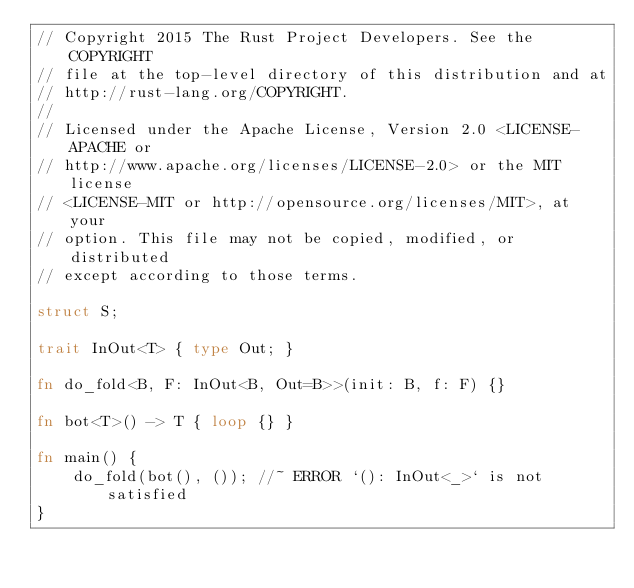Convert code to text. <code><loc_0><loc_0><loc_500><loc_500><_Rust_>// Copyright 2015 The Rust Project Developers. See the COPYRIGHT
// file at the top-level directory of this distribution and at
// http://rust-lang.org/COPYRIGHT.
//
// Licensed under the Apache License, Version 2.0 <LICENSE-APACHE or
// http://www.apache.org/licenses/LICENSE-2.0> or the MIT license
// <LICENSE-MIT or http://opensource.org/licenses/MIT>, at your
// option. This file may not be copied, modified, or distributed
// except according to those terms.

struct S;

trait InOut<T> { type Out; }

fn do_fold<B, F: InOut<B, Out=B>>(init: B, f: F) {}

fn bot<T>() -> T { loop {} }

fn main() {
    do_fold(bot(), ()); //~ ERROR `(): InOut<_>` is not satisfied
}
</code> 